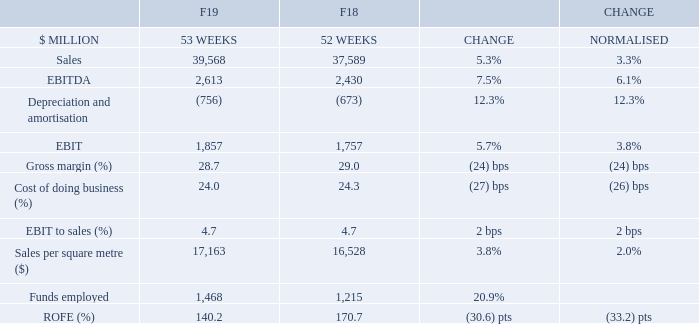Australian Food’s VOC NPS (including Online) was up 3 pts on the prior year with Store‐controllable VOC steady on the prior year. Store‐controllable VOC improved on Q3’19 where scores were impacted by flood and drought effects on fruit and vegetable prices impacting quality and availability. Fruit & Vegetables and Availability scores improved 1 pt to 78% compared to June 2018, and 5 pts and 2 pts respectively vs. Q3’19. Team Attitude remained stable (89%) compared to June 2018.
In F20, Store‐controllable VOC will be reduced from seven metrics to five, removing Ease of Movement and Correct Price Tickets to simplify the focus for stores on the areas that offer the most opportunity for improvement.
Sales increased by 5.3% to $39.6 billion or 3.3% on a normalised basis. Comparable sales increased by 3.1% for the year with transaction growth of 1.8% and items per basket of 1.7% contributing to comparable item growth of 3.5%.
Despite some challenges during the year, sales momentum improved in H2 with strong growth across a number of Fresh categories. Sales in the second half also benefitted from successful campaigns including Disney Words and Earn & Learn. In Q4, comparable sales increased by 3.6% with comparable transaction growth of 1.4%. Comparable items per basket increased by 1.2%.
Metro continued to grow strongly with further refinement to price, promotional optimisation and range curation. An extra‐small store format was successfully launched in Kirribilli and new stores opened in Rozelle and Kings Cross. At the end of the financial year, 43 Metro‐branded stores and 16 small Woolworths Supermarkets were managed by the Metro team.
In WooliesX, Online VOC scores improved 2 pts to 81% at the end of June, with improvements in Delivery & Pick up and Ease of Website Navigation. Online sales grew 31% (normalised) to $1.4 billion driven by expanded offerings such as Same day, Delivery Now, Drive thru and Drive up.
Australian Food sales per square metre was $17,163 with normalised growth of 2.0% on the prior year. During the year, 24 new stores were opened (21 supermarkets and three Metros), eight were closed and 68 Renewals completed. At year‐end, there were 1,024 Woolworths Supermarkets and Metro stores.
Average prices declined 0.4% for the year, with modest inflation of 0.5% in the fourth quarter as a result of increases in a number of Fresh categories impacted by the drought including Fruit & Vegetables, Meat and Bakery.
How many Woolworths Supermarkets were managed by the Metro team by the end of the financial year? 16. What is the percentage change for Sales during this financial year? 5.3%. How many Metro-branded stores were managed by the Metro team by the end of the financial year? 43. What is the percentage of Depreciation and amortisation in EBITDA in F19?
Answer scale should be: percent. (756/2,613) 
Answer: 28.93. What is the percentage of EBIT in EBITDA?
Answer scale should be: percent. (1,857/2,613) 
Answer: 71.07. What is the nominal difference for Sales between F19 and F18?
Answer scale should be: million. 39,568 - 37,589 
Answer: 1979. 